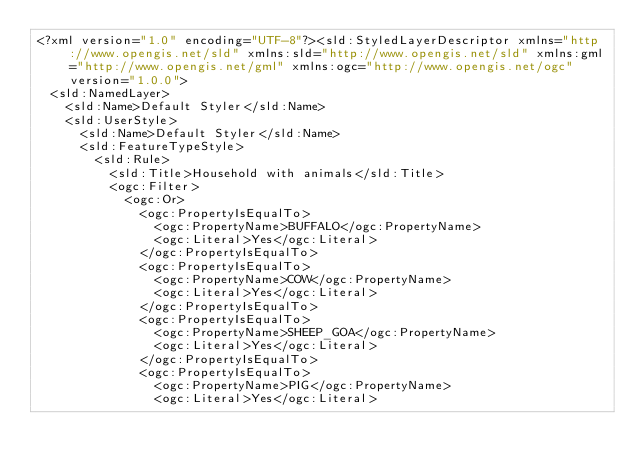<code> <loc_0><loc_0><loc_500><loc_500><_Scheme_><?xml version="1.0" encoding="UTF-8"?><sld:StyledLayerDescriptor xmlns="http://www.opengis.net/sld" xmlns:sld="http://www.opengis.net/sld" xmlns:gml="http://www.opengis.net/gml" xmlns:ogc="http://www.opengis.net/ogc" version="1.0.0">
  <sld:NamedLayer>
    <sld:Name>Default Styler</sld:Name>
    <sld:UserStyle>
      <sld:Name>Default Styler</sld:Name>
      <sld:FeatureTypeStyle>
        <sld:Rule>
          <sld:Title>Household with animals</sld:Title>
          <ogc:Filter>
            <ogc:Or>
              <ogc:PropertyIsEqualTo>
                <ogc:PropertyName>BUFFALO</ogc:PropertyName>
                <ogc:Literal>Yes</ogc:Literal>
              </ogc:PropertyIsEqualTo>
              <ogc:PropertyIsEqualTo>
                <ogc:PropertyName>COW</ogc:PropertyName>
                <ogc:Literal>Yes</ogc:Literal>
              </ogc:PropertyIsEqualTo>
              <ogc:PropertyIsEqualTo>
                <ogc:PropertyName>SHEEP_GOA</ogc:PropertyName>
                <ogc:Literal>Yes</ogc:Literal>
              </ogc:PropertyIsEqualTo>
              <ogc:PropertyIsEqualTo>
                <ogc:PropertyName>PIG</ogc:PropertyName>
                <ogc:Literal>Yes</ogc:Literal></code> 